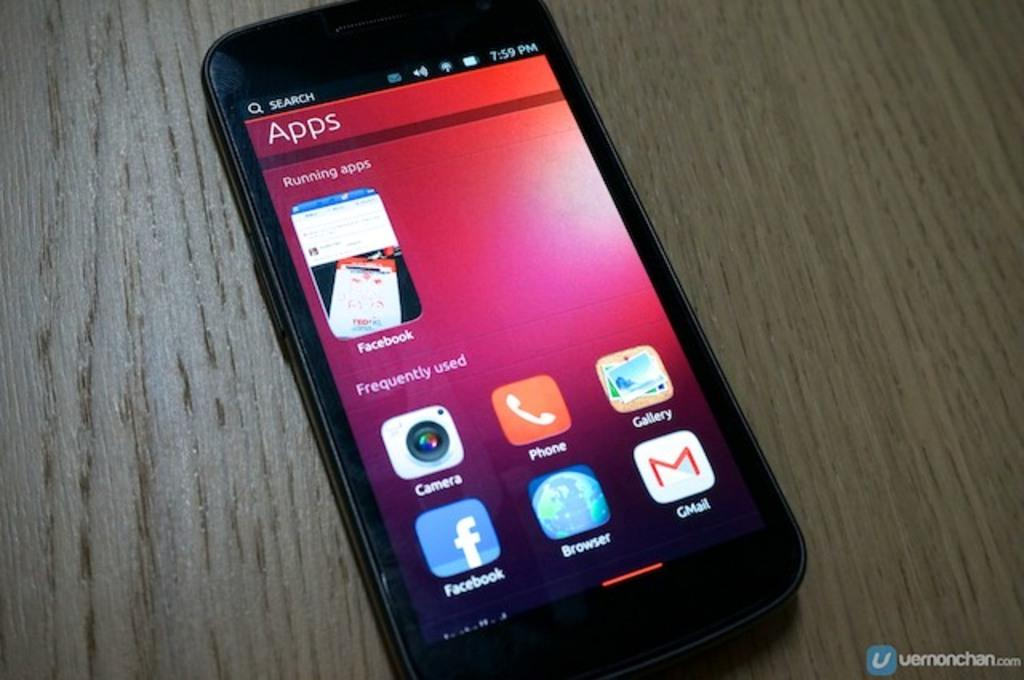Provide a one-sentence caption for the provided image. A phone screen displays "running apps" and apps that are "frequently used.". 